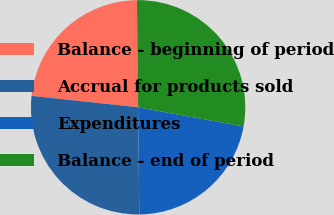Convert chart. <chart><loc_0><loc_0><loc_500><loc_500><pie_chart><fcel>Balance - beginning of period<fcel>Accrual for products sold<fcel>Expenditures<fcel>Balance - end of period<nl><fcel>23.12%<fcel>26.88%<fcel>21.96%<fcel>28.04%<nl></chart> 